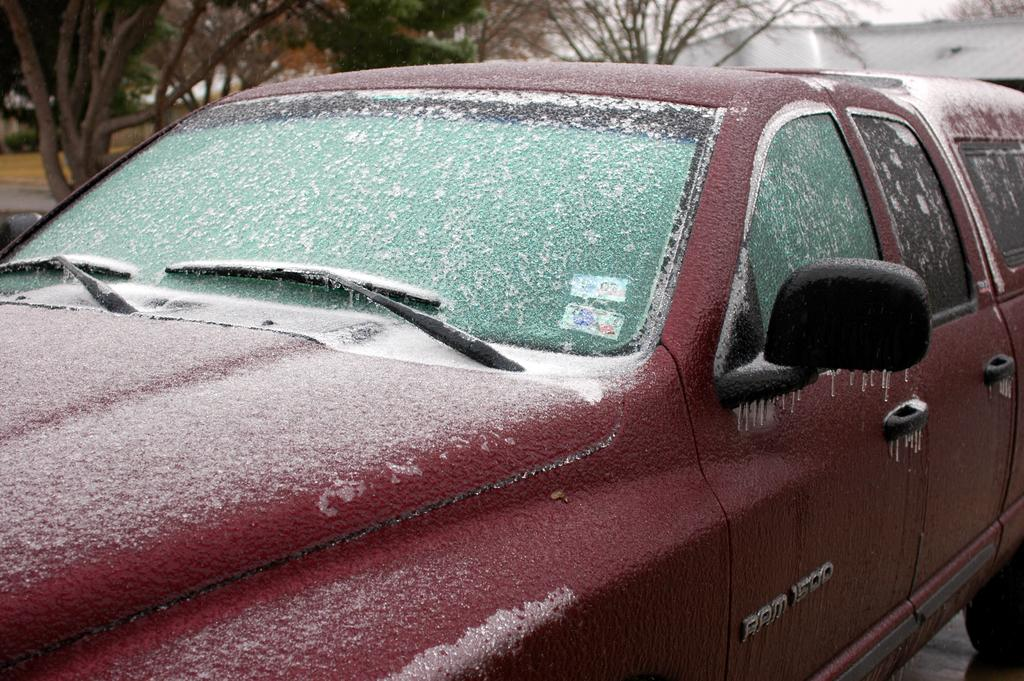What color is the car in the picture? The car in the picture is red. What is covering the car in the picture? The car has snow on it. What can be seen in the background of the picture? There are trees and other objects visible in the background of the picture. What instrument is the car playing in the picture? There is no instrument present in the picture, and the car is not playing any instrument. 